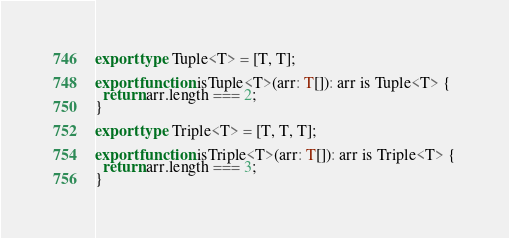<code> <loc_0><loc_0><loc_500><loc_500><_TypeScript_>export type Tuple<T> = [T, T];

export function isTuple<T>(arr: T[]): arr is Tuple<T> {
  return arr.length === 2;
}

export type Triple<T> = [T, T, T];

export function isTriple<T>(arr: T[]): arr is Triple<T> {
  return arr.length === 3;
}
</code> 